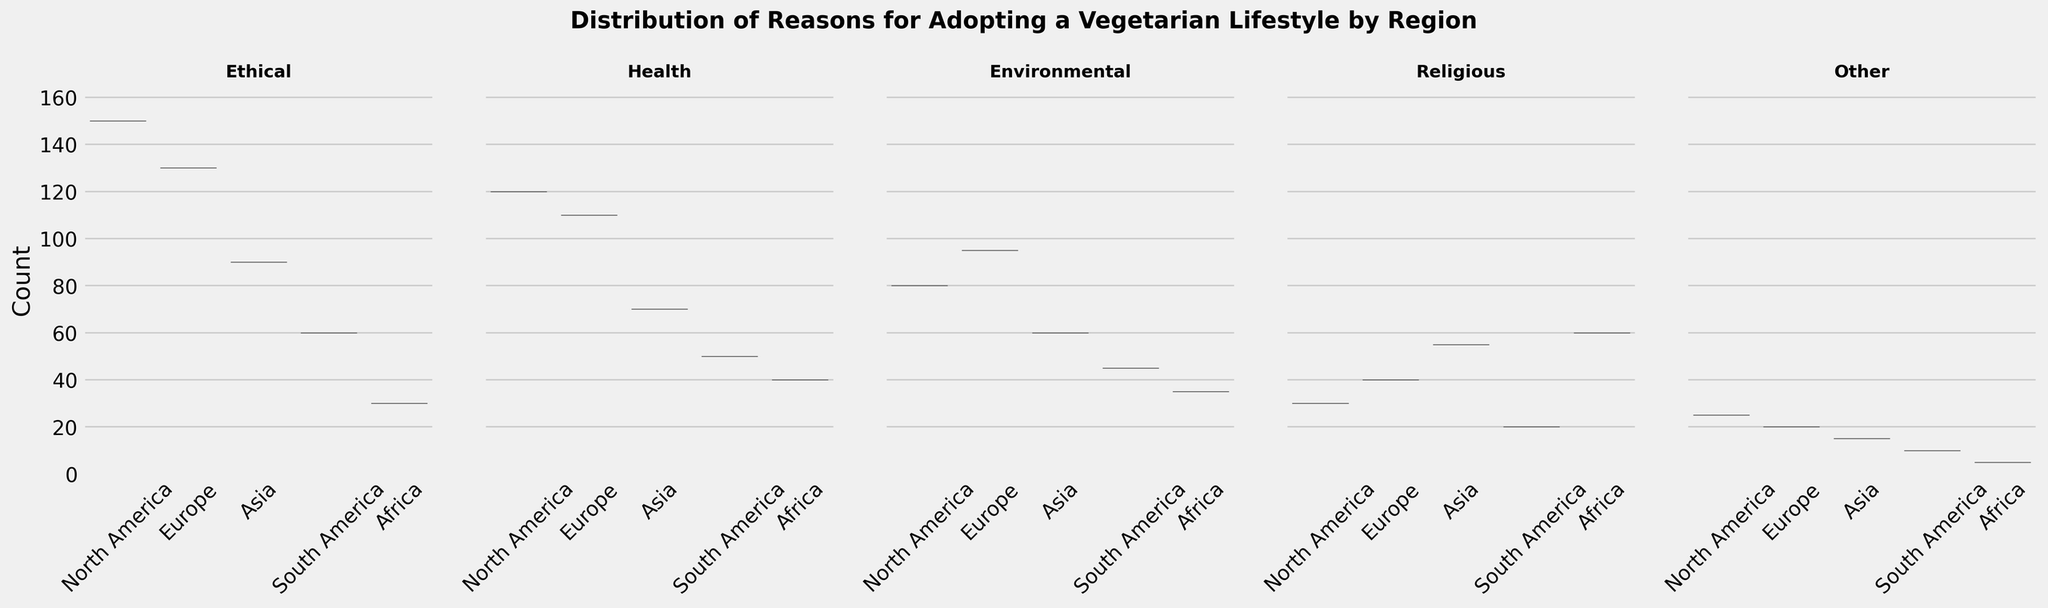What's the title of the figure? The title is displayed at the top center of the figure in bold letters. It summarizes the main topic of the plot: "Distribution of Reasons for Adopting a Vegetarian Lifestyle by Region".
Answer: Distribution of Reasons for Adopting a Vegetarian Lifestyle by Region How many subplot charts are there? We see that there are five violin plots placed side by side within the figure. Each subplot corresponds to a different reason for adopting a vegetarian lifestyle.
Answer: Five Which region has the highest count for ethical reasons? Observing the violin plots under the title "Ethical", we can see that the highest point is marked for North America.
Answer: North America What is the maximum count for health reasons, and in which region does it occur? Looking at the violin plot under the title "Health", the highest peak occurs at around 120, which is specific to North America.
Answer: 120, North America Compare the counts for environmental reasons between North America and Europe. The violin plot under "Environmental" shows that North America has a peak around 80 and Europe around 95. By comparing these peaks visually, Europe has a higher count.
Answer: Europe Are ethical reasons more popular than health reasons in Africa? By checking the respective violin plots for "Ethical" and "Health", the peaks for ethical reasons and health reasons in Africa appear at 30 and 40 respectively. Thus, health reasons are more popular in Africa.
Answer: No Which reason has the highest variance in counts across regions? By observing the shapes of the violin plots, the height and spread of the plots indicate variance. The plot under "Ethical" appears to have the widest spread, implying the highest variance.
Answer: Ethical Is there a region where religious reasons have the highest count compared to other reasons? Observing the religious plot, the peaks are compared with all other respective reasons. It can be seen that in Africa, the peak for religious reasons (60) is higher than any other reasons mentioned for Africa.
Answer: Yes What can you infer about the popularity of reasons for adopting a vegetarian lifestyle in Asia? By observing the peaks across all violin plots for Asia, health and religious reasons have higher counts compared to others, indicating their relative popularity.
Answer: Health and Religious Is the count for 'Other' reasons uniformly distributed across regions? Observing the "Other" violin plot, the spread of data points does not appear to be uniform; the plot is noticeably thinner, indicating lower counts and fewer variations in most regions with a peak in North America.
Answer: No 